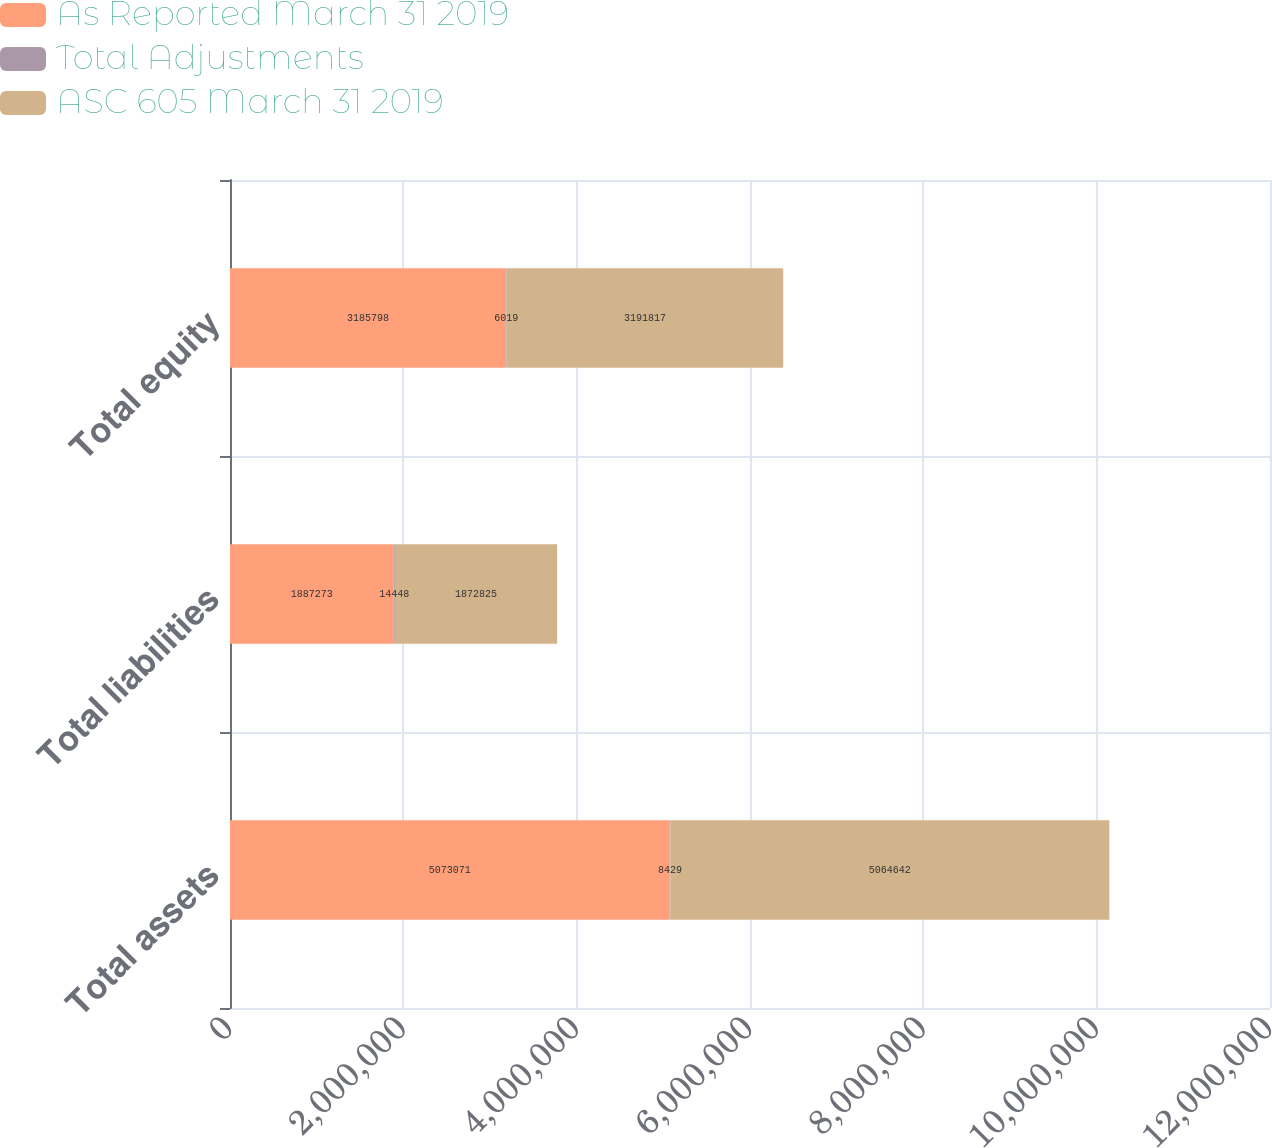Convert chart. <chart><loc_0><loc_0><loc_500><loc_500><stacked_bar_chart><ecel><fcel>Total assets<fcel>Total liabilities<fcel>Total equity<nl><fcel>As Reported March 31 2019<fcel>5.07307e+06<fcel>1.88727e+06<fcel>3.1858e+06<nl><fcel>Total Adjustments<fcel>8429<fcel>14448<fcel>6019<nl><fcel>ASC 605 March 31 2019<fcel>5.06464e+06<fcel>1.87282e+06<fcel>3.19182e+06<nl></chart> 